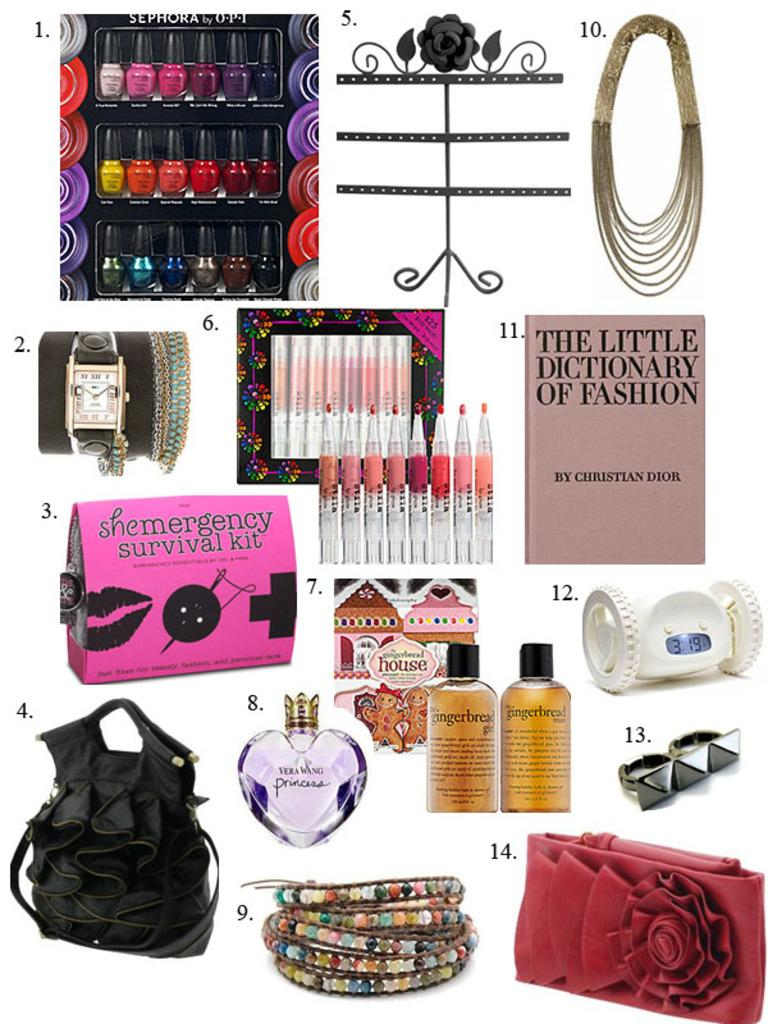Provide a one-sentence caption for the provided image. Several different items on a page, one being a book titled The Little Dictionary of Fashion. 